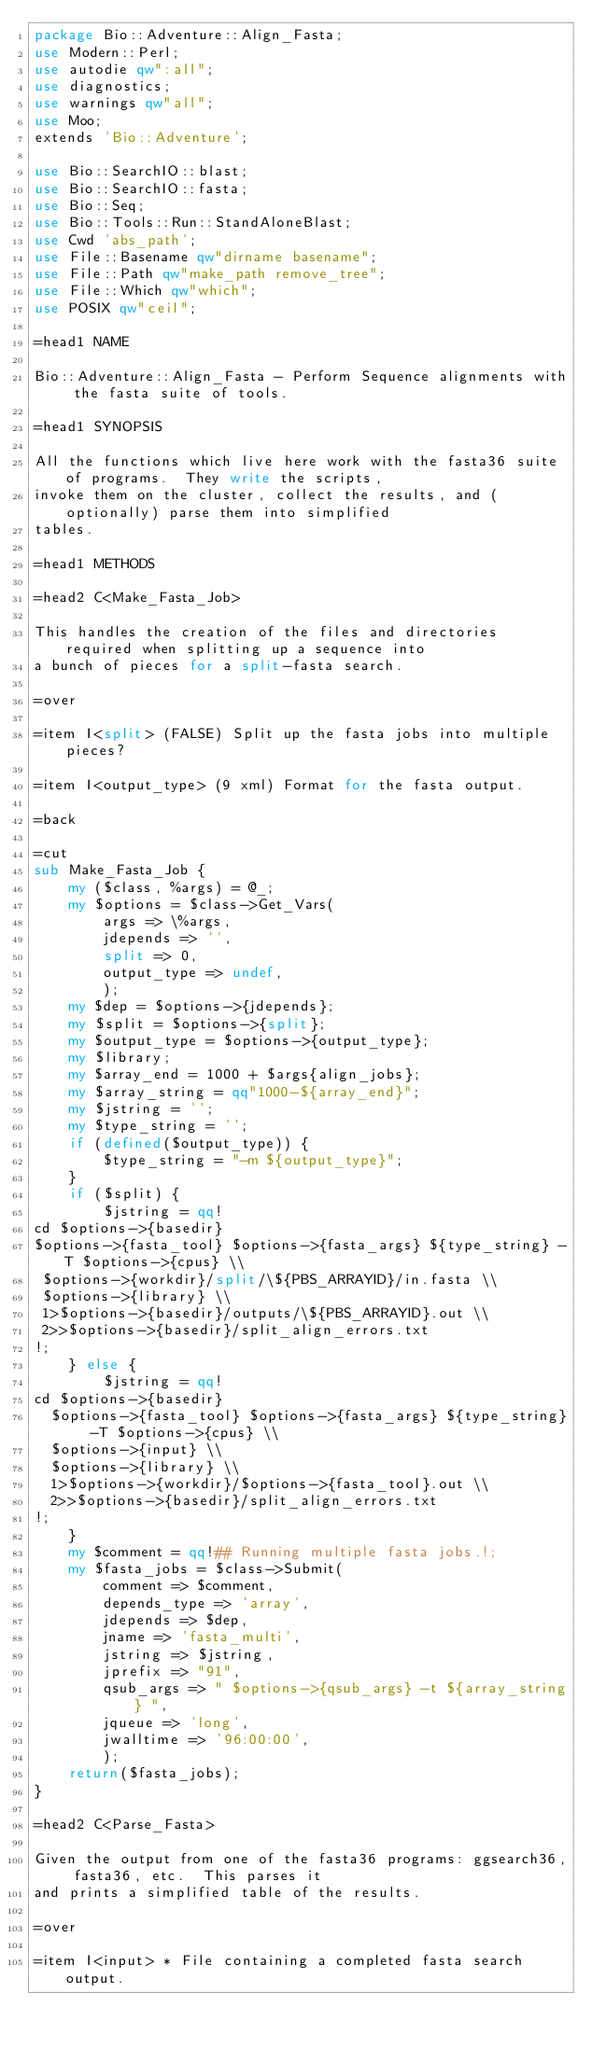<code> <loc_0><loc_0><loc_500><loc_500><_Perl_>package Bio::Adventure::Align_Fasta;
use Modern::Perl;
use autodie qw":all";
use diagnostics;
use warnings qw"all";
use Moo;
extends 'Bio::Adventure';

use Bio::SearchIO::blast;
use Bio::SearchIO::fasta;
use Bio::Seq;
use Bio::Tools::Run::StandAloneBlast;
use Cwd 'abs_path';
use File::Basename qw"dirname basename";
use File::Path qw"make_path remove_tree";
use File::Which qw"which";
use POSIX qw"ceil";

=head1 NAME

Bio::Adventure::Align_Fasta - Perform Sequence alignments with the fasta suite of tools.

=head1 SYNOPSIS

All the functions which live here work with the fasta36 suite of programs.  They write the scripts,
invoke them on the cluster, collect the results, and (optionally) parse them into simplified
tables.

=head1 METHODS

=head2 C<Make_Fasta_Job>

This handles the creation of the files and directories required when splitting up a sequence into
a bunch of pieces for a split-fasta search.

=over

=item I<split> (FALSE) Split up the fasta jobs into multiple pieces?

=item I<output_type> (9 xml) Format for the fasta output.

=back

=cut
sub Make_Fasta_Job {
    my ($class, %args) = @_;
    my $options = $class->Get_Vars(
        args => \%args,
        jdepends => '',
        split => 0,
        output_type => undef,
        );
    my $dep = $options->{jdepends};
    my $split = $options->{split};
    my $output_type = $options->{output_type};
    my $library;
    my $array_end = 1000 + $args{align_jobs};
    my $array_string = qq"1000-${array_end}";
    my $jstring = '';
    my $type_string = '';
    if (defined($output_type)) {
        $type_string = "-m ${output_type}";
    }
    if ($split) {
        $jstring = qq!
cd $options->{basedir}
$options->{fasta_tool} $options->{fasta_args} ${type_string} -T $options->{cpus} \\
 $options->{workdir}/split/\${PBS_ARRAYID}/in.fasta \\
 $options->{library} \\
 1>$options->{basedir}/outputs/\${PBS_ARRAYID}.out \\
 2>>$options->{basedir}/split_align_errors.txt
!;
    } else {
        $jstring = qq!
cd $options->{basedir}
  $options->{fasta_tool} $options->{fasta_args} ${type_string} -T $options->{cpus} \\
  $options->{input} \\
  $options->{library} \\
  1>$options->{workdir}/$options->{fasta_tool}.out \\
  2>>$options->{basedir}/split_align_errors.txt
!;
    }
    my $comment = qq!## Running multiple fasta jobs.!;
    my $fasta_jobs = $class->Submit(
        comment => $comment,
        depends_type => 'array',
        jdepends => $dep,
        jname => 'fasta_multi',
        jstring => $jstring,
        jprefix => "91",
        qsub_args => " $options->{qsub_args} -t ${array_string} ",
        jqueue => 'long',
        jwalltime => '96:00:00',
        );
    return($fasta_jobs);
}

=head2 C<Parse_Fasta>

Given the output from one of the fasta36 programs: ggsearch36, fasta36, etc.  This parses it
and prints a simplified table of the results.

=over

=item I<input> * File containing a completed fasta search output.
</code> 